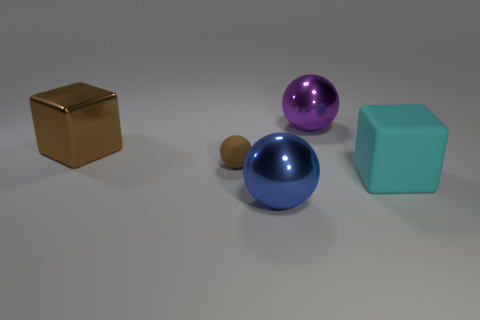What is the shape of the large cyan thing? cube 